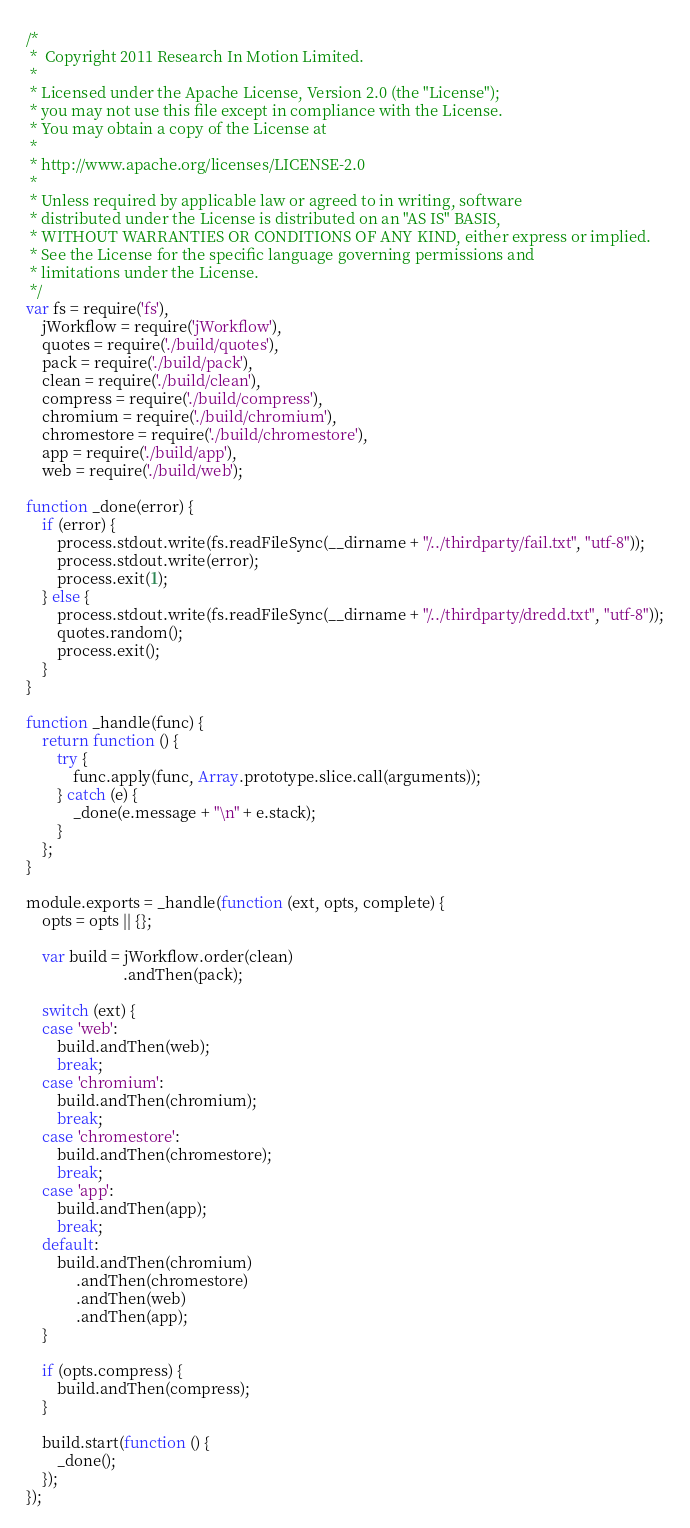<code> <loc_0><loc_0><loc_500><loc_500><_JavaScript_>/*
 *  Copyright 2011 Research In Motion Limited.
 *
 * Licensed under the Apache License, Version 2.0 (the "License");
 * you may not use this file except in compliance with the License.
 * You may obtain a copy of the License at
 *
 * http://www.apache.org/licenses/LICENSE-2.0
 *
 * Unless required by applicable law or agreed to in writing, software
 * distributed under the License is distributed on an "AS IS" BASIS,
 * WITHOUT WARRANTIES OR CONDITIONS OF ANY KIND, either express or implied.
 * See the License for the specific language governing permissions and
 * limitations under the License.
 */
var fs = require('fs'),
    jWorkflow = require('jWorkflow'),
    quotes = require('./build/quotes'),
    pack = require('./build/pack'),
    clean = require('./build/clean'),
    compress = require('./build/compress'),
    chromium = require('./build/chromium'),
    chromestore = require('./build/chromestore'),
    app = require('./build/app'),
    web = require('./build/web');

function _done(error) {
    if (error) {
        process.stdout.write(fs.readFileSync(__dirname + "/../thirdparty/fail.txt", "utf-8"));
        process.stdout.write(error);
        process.exit(1);
    } else {
        process.stdout.write(fs.readFileSync(__dirname + "/../thirdparty/dredd.txt", "utf-8"));
        quotes.random();
        process.exit();
    }
}

function _handle(func) {
    return function () {
        try {
            func.apply(func, Array.prototype.slice.call(arguments));
        } catch (e) {
            _done(e.message + "\n" + e.stack);
        }
    };
}

module.exports = _handle(function (ext, opts, complete) {
    opts = opts || {};

    var build = jWorkflow.order(clean)
                         .andThen(pack);

    switch (ext) {
    case 'web':
        build.andThen(web);
        break;
    case 'chromium':
        build.andThen(chromium);
        break;
    case 'chromestore':
        build.andThen(chromestore);
        break;
    case 'app':
        build.andThen(app);
        break;
    default:
        build.andThen(chromium)
             .andThen(chromestore)
             .andThen(web)
             .andThen(app);
    }

    if (opts.compress) {
        build.andThen(compress);
    }

    build.start(function () {
        _done();
    });
});
</code> 